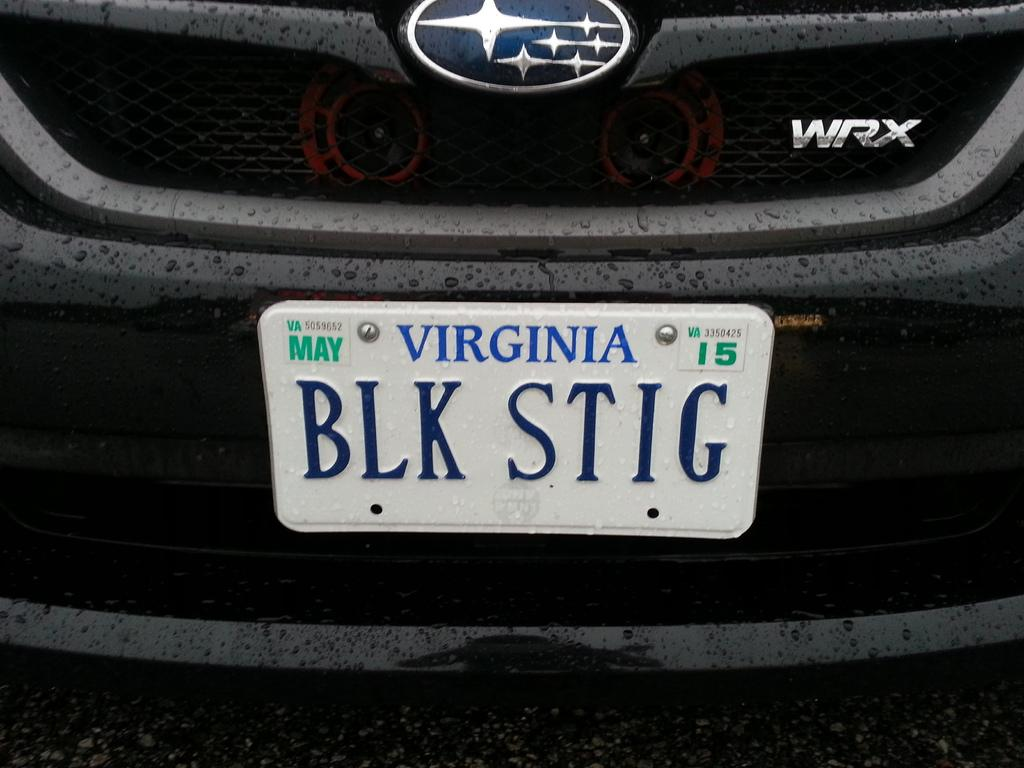<image>
Give a short and clear explanation of the subsequent image. A Subaru model WRX with a Virginia license plate that says BLK STIG. 